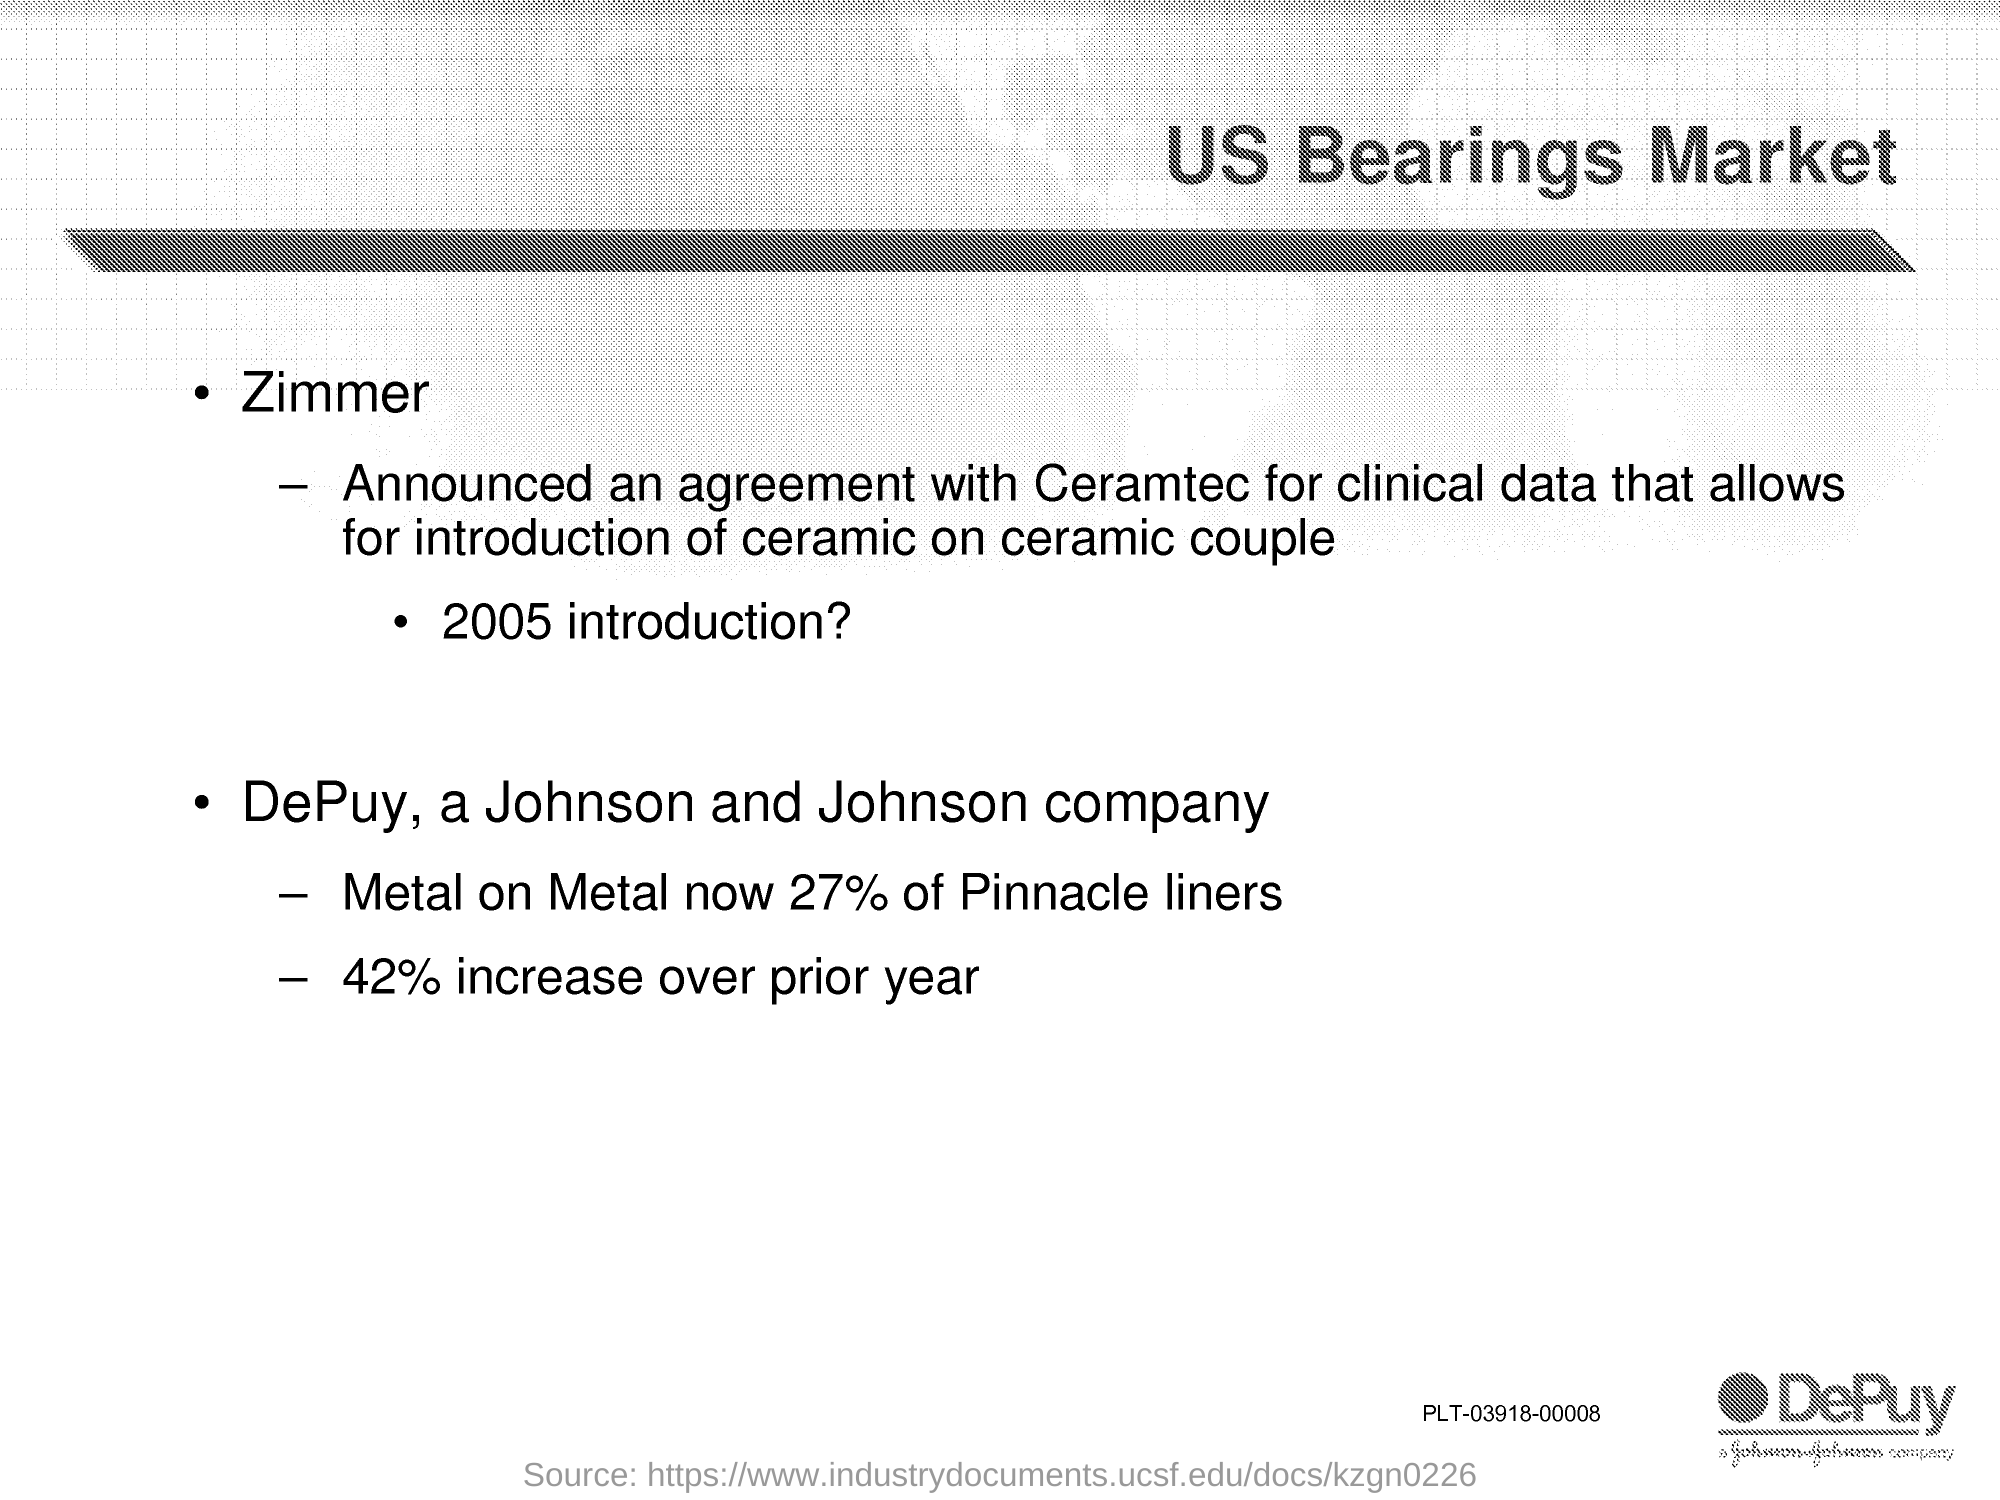Indicate a few pertinent items in this graphic. The title of the document is 'What is the Bearings Market in the United States?' 